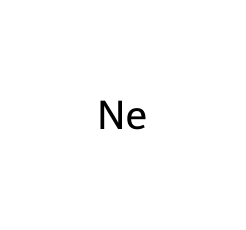What is the atomic number of neon? The atomic number of a chemical is defined by the number of protons in its nucleus. Neon, represented by the SMILES notation [Ne], has an atomic number of 10, which means it has 10 protons.
Answer: 10 How many electrons does a neutral neon atom have? In a neutral atom, the number of electrons equals the number of protons. Since neon has an atomic number of 10, it has 10 electrons.
Answer: 10 What is the main use of neon in vintage signs? Neon is used in signage primarily for its ability to emit bright colors when an electric current passes through it. This property makes it popular in neon signs, especially in the 1960s.
Answer: signage Is neon a reactive gas? Neon is classified as a noble gas, which are known for their lack of reactivity due to having a full outer electron shell. Therefore, neon is characterized as a non-reactive or inert gas.
Answer: non-reactive What color does neon emit when ionized? When ionized, neon emits a bright reddish-orange color. This distinctive coloration is a result of the specific wavelengths of light released by excited neon atoms returning to their ground state.
Answer: reddish-orange How does the atomic structure of neon differentiate it from other gases? Neon has a completely filled outer electron shell with 10 electrons, which is characteristic of noble gases. This fully filled shell is what sets neon apart from other gases, which typically have unfilled shells and thus exhibit reactivity.
Answer: fully filled outer shell 